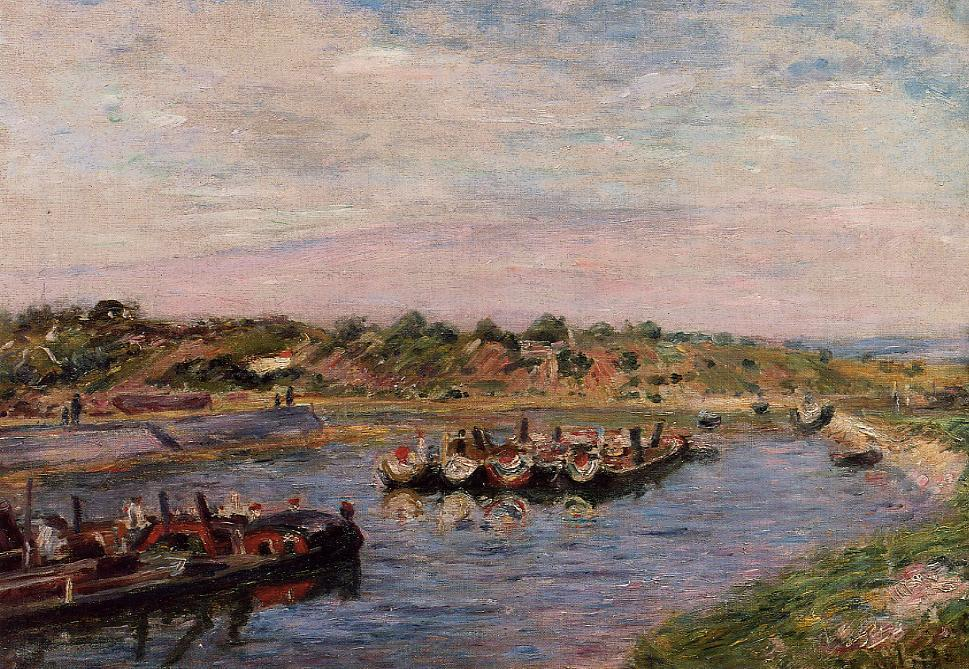What might be the historical or cultural significance of the scene depicted in this painting? The scene depicted in this impressionist painting may hold significant historical or cultural value. It likely captures a moment during a local festival or celebration along the river. Such scenes were common during the late 19th to early 20th centuries in Europe, particularly in France, where rivers were central to the community's social and economic life. The boats and their festive decorations could indicate a special event, possibly tied to regional traditions or maritime activities. The presence of people in colorful attire suggests the communal and joyous spirit of the occasion, reflecting the period's cultural emphasis on leisure and social gatherings. 